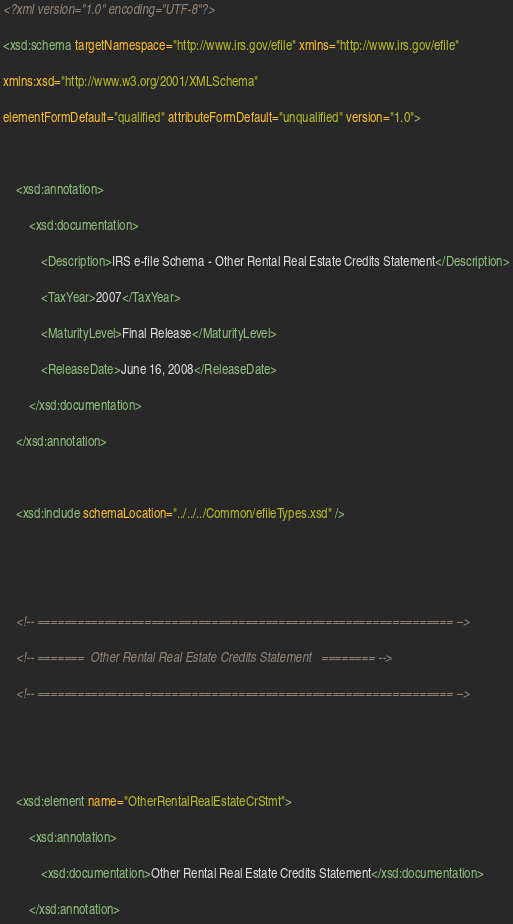Convert code to text. <code><loc_0><loc_0><loc_500><loc_500><_XML_><?xml version="1.0" encoding="UTF-8"?>
<xsd:schema targetNamespace="http://www.irs.gov/efile" xmlns="http://www.irs.gov/efile" 
xmlns:xsd="http://www.w3.org/2001/XMLSchema" 
elementFormDefault="qualified" attributeFormDefault="unqualified" version="1.0">

	<xsd:annotation>
		<xsd:documentation>
			<Description>IRS e-file Schema - Other Rental Real Estate Credits Statement</Description>
			<TaxYear>2007</TaxYear>
			<MaturityLevel>Final Release</MaturityLevel>
			<ReleaseDate>June 16, 2008</ReleaseDate>
		</xsd:documentation>
	</xsd:annotation>

	<xsd:include schemaLocation="../../../Common/efileTypes.xsd" />


	<!-- ============================================================== -->
	<!-- =======  Other Rental Real Estate Credits Statement   ======== -->
	<!-- ============================================================== -->


	<xsd:element name="OtherRentalRealEstateCrStmt">
		<xsd:annotation>
			<xsd:documentation>Other Rental Real Estate Credits Statement</xsd:documentation>
		</xsd:annotation></code> 